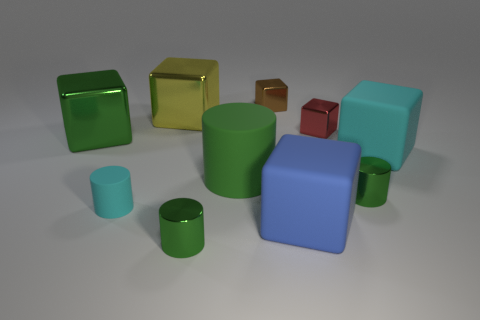What is the small brown thing made of?
Your answer should be very brief. Metal. There is another object that is the same color as the small matte thing; what material is it?
Ensure brevity in your answer.  Rubber. Does the big metallic object that is in front of the red thing have the same shape as the yellow shiny object?
Ensure brevity in your answer.  Yes. How many things are big rubber blocks or metallic blocks?
Keep it short and to the point. 6. Is the big cube left of the big yellow thing made of the same material as the large cyan block?
Provide a succinct answer. No. The blue cube has what size?
Offer a very short reply. Large. How many cylinders are either big shiny objects or tiny brown metal objects?
Keep it short and to the point. 0. Are there the same number of small shiny objects in front of the large yellow metallic block and yellow cubes that are in front of the blue rubber thing?
Provide a short and direct response. No. What size is the other rubber thing that is the same shape as the tiny matte thing?
Your answer should be very brief. Large. There is a object that is to the left of the large cyan block and right of the tiny red shiny cube; what size is it?
Your answer should be very brief. Small. 